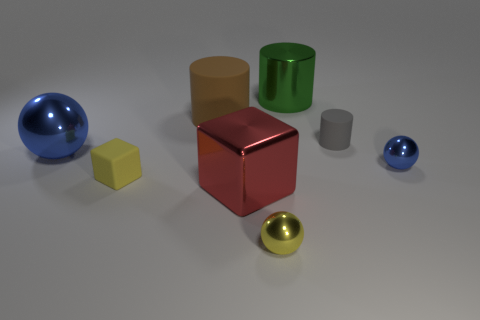There is a sphere that is the same color as the small matte block; what is its size?
Your answer should be compact. Small. Is there a small shiny thing that has the same color as the big metallic ball?
Give a very brief answer. Yes. What number of other things are there of the same size as the red shiny thing?
Your answer should be very brief. 3. What number of big things are either gray rubber objects or red objects?
Keep it short and to the point. 1. Does the gray matte object have the same size as the rubber thing in front of the small gray cylinder?
Your response must be concise. Yes. What number of other objects are the same shape as the yellow matte thing?
Your answer should be compact. 1. There is a tiny blue thing that is the same material as the red thing; what shape is it?
Make the answer very short. Sphere. Is there a small purple metallic cylinder?
Offer a very short reply. No. Are there fewer red shiny things behind the tiny gray matte thing than matte cubes on the right side of the green cylinder?
Provide a succinct answer. No. What shape is the big shiny object that is to the right of the tiny yellow shiny object?
Keep it short and to the point. Cylinder. 